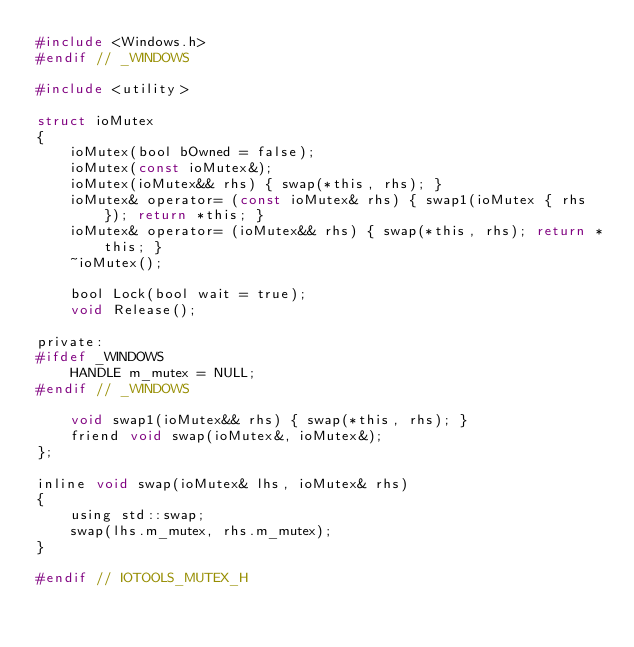<code> <loc_0><loc_0><loc_500><loc_500><_C_>#include <Windows.h>
#endif // _WINDOWS

#include <utility>

struct ioMutex
{
	ioMutex(bool bOwned = false);
	ioMutex(const ioMutex&);
	ioMutex(ioMutex&& rhs) { swap(*this, rhs); }
	ioMutex& operator= (const ioMutex& rhs) { swap1(ioMutex { rhs }); return *this; }
	ioMutex& operator= (ioMutex&& rhs) { swap(*this, rhs); return *this; }
	~ioMutex();

	bool Lock(bool wait = true);
	void Release();

private:
#ifdef _WINDOWS
	HANDLE m_mutex = NULL;
#endif // _WINDOWS

	void swap1(ioMutex&& rhs) { swap(*this, rhs); }
	friend void swap(ioMutex&, ioMutex&);
};

inline void swap(ioMutex& lhs, ioMutex& rhs)
{
	using std::swap;
	swap(lhs.m_mutex, rhs.m_mutex);
}

#endif // IOTOOLS_MUTEX_H
</code> 